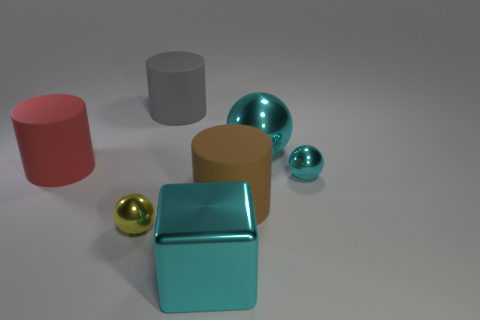Subtract all purple cylinders. Subtract all yellow blocks. How many cylinders are left? 3 Subtract all blue cylinders. How many purple blocks are left? 0 Add 3 grays. How many browns exist? 0 Subtract all large gray matte cubes. Subtract all red things. How many objects are left? 6 Add 5 red things. How many red things are left? 6 Add 3 small red cubes. How many small red cubes exist? 3 Add 3 matte objects. How many objects exist? 10 Subtract all red cylinders. How many cylinders are left? 2 Subtract all large gray matte cylinders. How many cylinders are left? 2 Subtract 0 cyan cylinders. How many objects are left? 7 